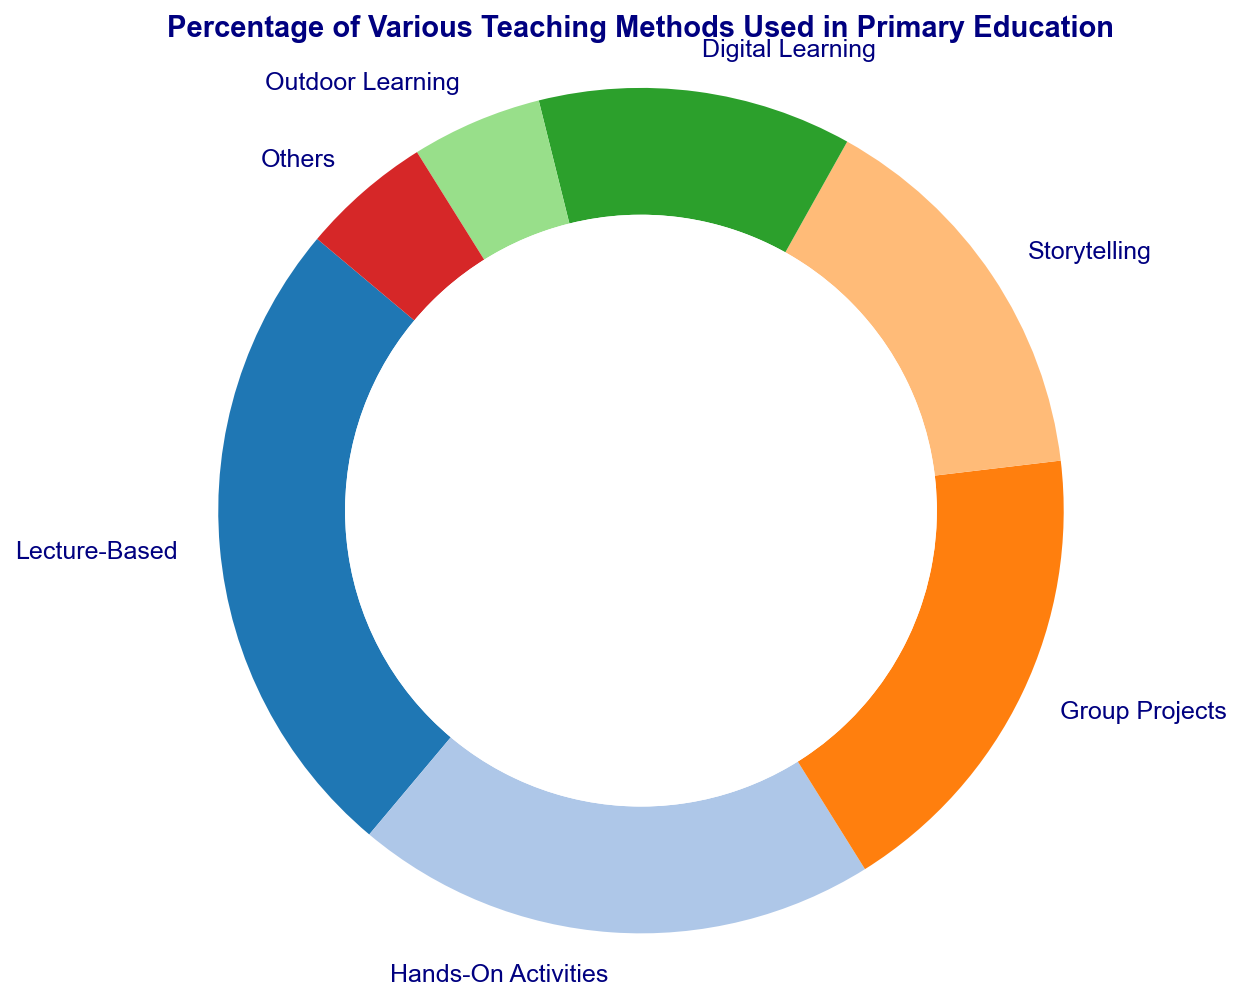What's the most frequently used teaching method in primary education shown in the figure? The figure indicates that Lecture-Based method occupies the largest portion of the ring chart. Since sizes and labels are shown clearly, we can identify that it's Lecture-Based with 25%.
Answer: Lecture-Based How does the percentage of Hands-On Activities compare to Digital Learning? From the ring chart, Hands-On Activities represent 20% while Digital Learning represents 12%. By visually comparing the slices, Hands-On Activities forms a larger segment than Digital Learning.
Answer: Hands-On Activities is greater What is the combined percentage of Group Projects and Storytelling methods? Group Projects account for 18%, and Storytelling accounts for 15%. Adding these together results in a combined percentage: 18% + 15% = 33%.
Answer: 33% Is there any teaching method that has the same percentage as Outdoor Learning in the chart? The figure shows Outdoor Learning at 5%. By examining the labels, we can find that Others also have the same percentage of 5%.
Answer: Yes, Others What’s the percentage difference between the largest and smallest teaching methods in the chart? The largest method is Lecture-Based at 25%, and both Outdoor Learning and Others are the smallest at 5%. The percentage difference is calculated as: 25% - 5% = 20%.
Answer: 20% Which teaching method has a higher percentage, Storytelling or Group Projects? The chart depicts Storytelling at 15% and Group Projects at 18%. By comparing these values, we can see that Group Projects has a higher percentage.
Answer: Group Projects What is the total percentage represented by non-digital methods (Lecture-Based, Hands-On Activities, Group Projects, Storytelling, Outdoor Learning, Others)? Summing up the percentages of the mentioned methods: 25% + 20% + 18% + 15% + 5% + 5% results in a total percentage of 88%.
Answer: 88% Which segment of the ring chart is the smallest, and which color is it represented by? Outdoor Learning and Others are the smallest segments at 5% each. Observing the ring chart colors, let's identify that Outdoor Learning might be represented by a certain color (depends on the chart but could be a specific shade) and likewise for Others.
Answer: Outdoor Learning and Others, [specific colors based on chart] How many teaching methods have a percentage of 10% or lower? Referring to the labels around the ring chart, we can see that Outdoor Learning and Others each have 5%. These are the only segments representing 10% or lower.
Answer: 2 